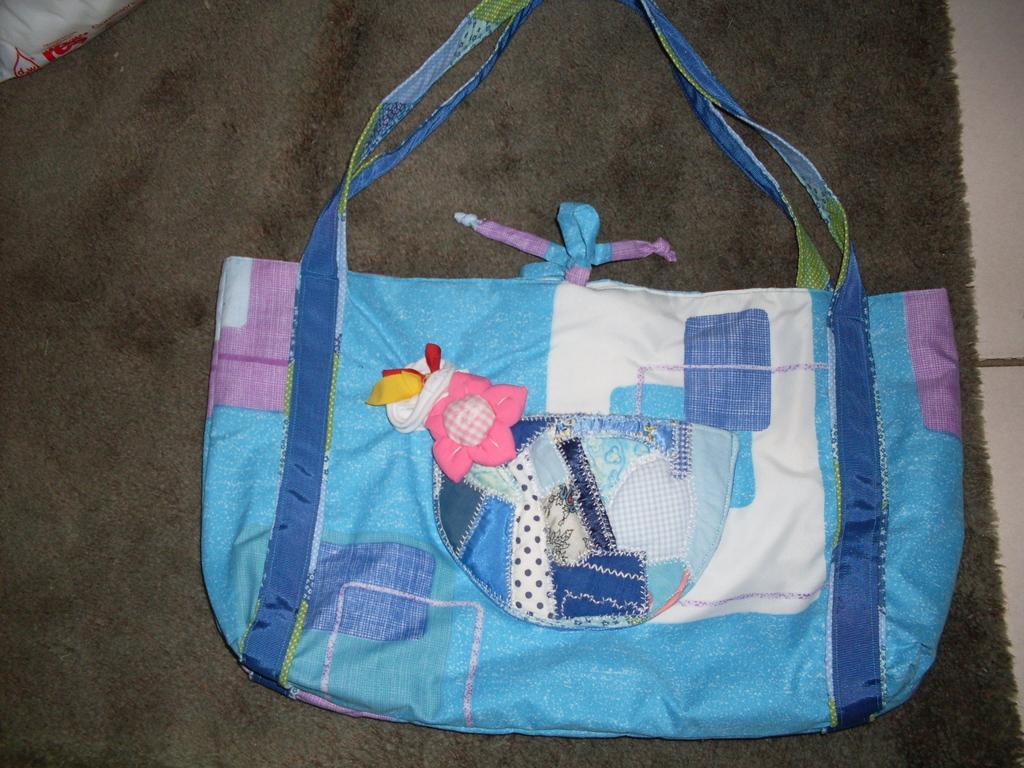Can you describe this image briefly? In this image I can see a handbag of blue color. 